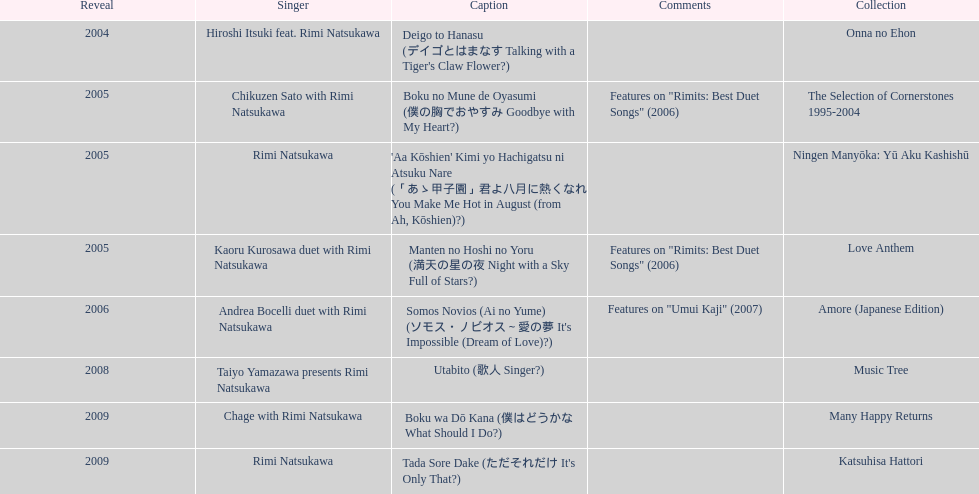What has been the last song this artist has made an other appearance on? Tada Sore Dake. 